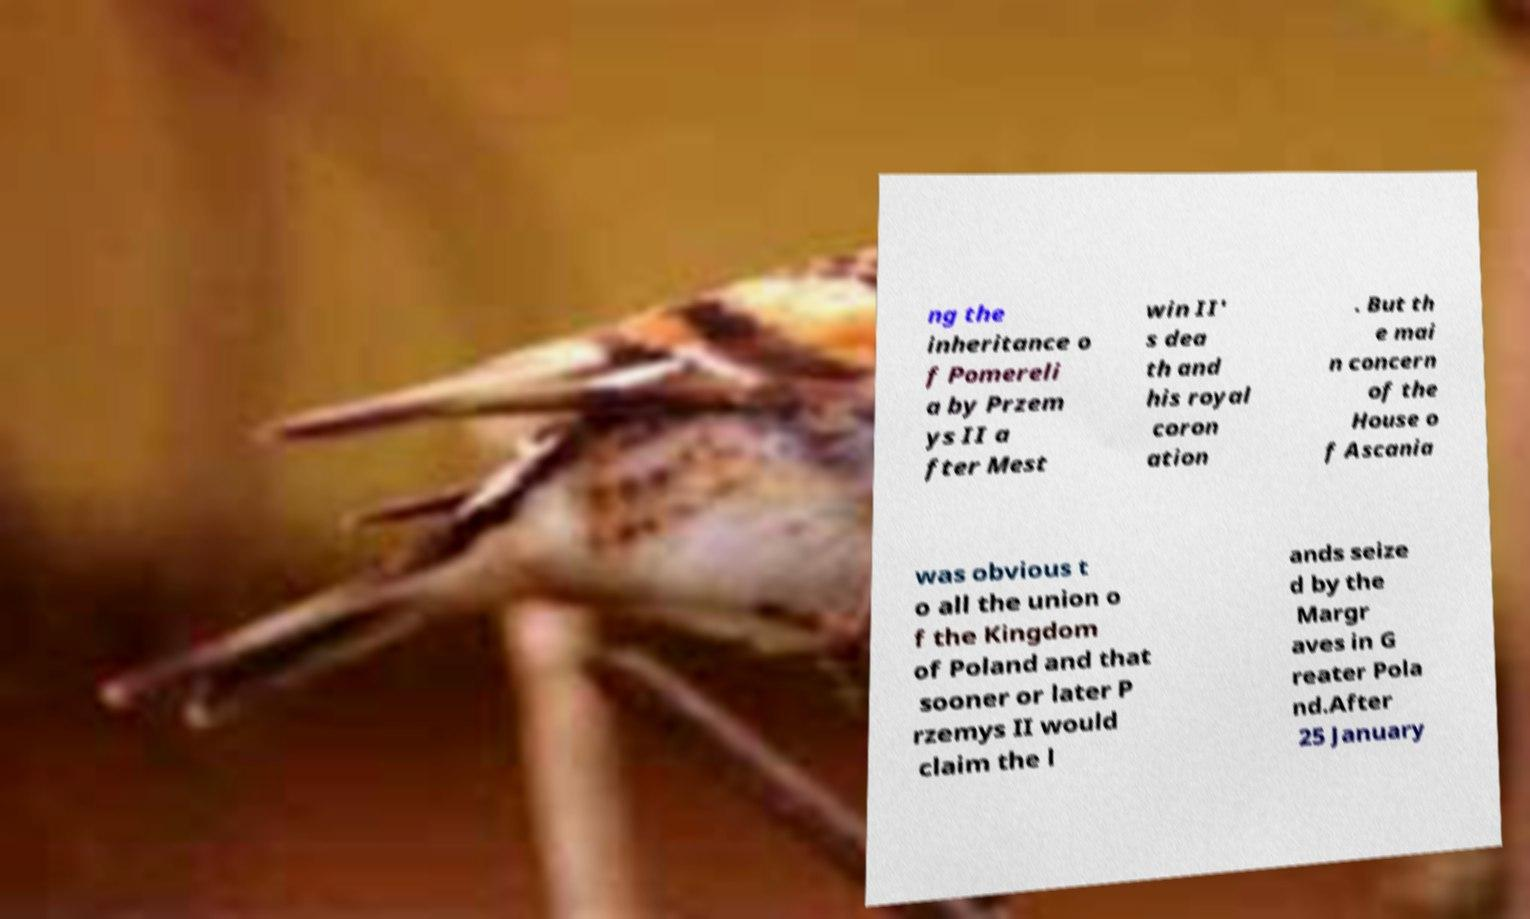Please identify and transcribe the text found in this image. ng the inheritance o f Pomereli a by Przem ys II a fter Mest win II' s dea th and his royal coron ation . But th e mai n concern of the House o f Ascania was obvious t o all the union o f the Kingdom of Poland and that sooner or later P rzemys II would claim the l ands seize d by the Margr aves in G reater Pola nd.After 25 January 